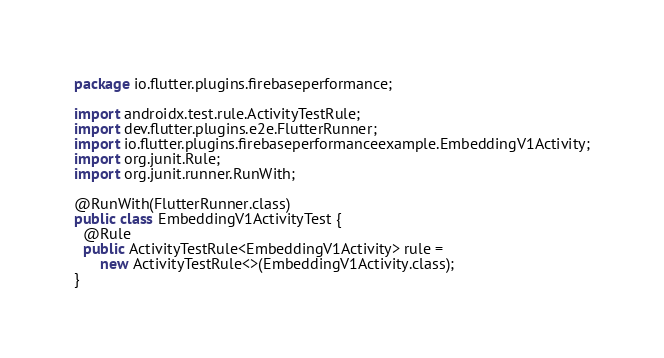Convert code to text. <code><loc_0><loc_0><loc_500><loc_500><_Java_>package io.flutter.plugins.firebaseperformance;

import androidx.test.rule.ActivityTestRule;
import dev.flutter.plugins.e2e.FlutterRunner;
import io.flutter.plugins.firebaseperformanceexample.EmbeddingV1Activity;
import org.junit.Rule;
import org.junit.runner.RunWith;

@RunWith(FlutterRunner.class)
public class EmbeddingV1ActivityTest {
  @Rule
  public ActivityTestRule<EmbeddingV1Activity> rule =
      new ActivityTestRule<>(EmbeddingV1Activity.class);
}
</code> 